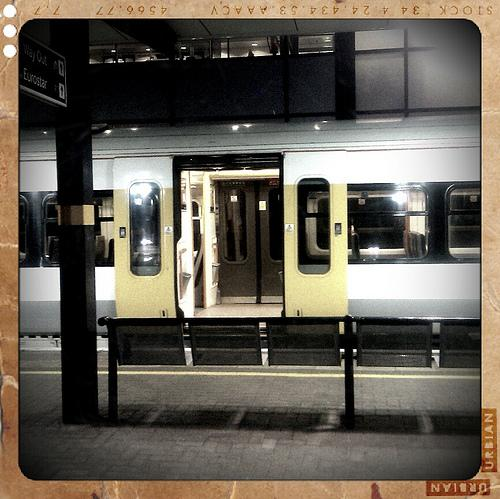What colors are the train doors described as? The train doors are described as white and yellow. What is the function of the mechanism in the image? The mechanism slides the doors open and closed on the train. Express the main sentiment of the image. The main sentiment of the image is of a quiet, empty subway train station waiting for passengers. Identify the primary mode of transportation in the image. The primary mode of transportation is an underground train. What type of pole is mentioned in the image? A metal support pole is mentioned. In the image, where is the light glare reflecting from? The light glare is reflecting off of the train window. Mention the state of the bench in the image. The bench is broken up into sections. List three objects present in the image. Three objects in the image are train, bench, and pillar. Describe the doorway in the image and its condition. The doorway is part of a train stopped at a station, and it is open. Observe the large, graffiti-covered trash can near the signpost. It adds an urban vibe to the station. There is no information about a trash can or graffiti in the given captions. The instruction misleads by implying there is an element of urban art in the image. Notice the cute kitten sitting on the platform, right next to the pillar. The instruction is misleading because there is no caption about a kitten in the given list. It creates a false expectation of seeing an animal in the image. Look for a group of people waiting for the train, gathered near the bench. They appear to be engaged in a conversation. This instruction is misleading because none of the captions mention any people in the image. It creates an incorrect impression of human presence in the scene. Do you see a big clock on the wall above the train door? It shows the current time. This instruction is misleading because there is no mention of a clock in the captions. It suggests that there is a time-telling element in the scene which does not exist. Can you spot the colorful advertisement poster on the wall opposite the train window? It promotes a new movie. There is no mention of an advertisement or poster in any of the given captions. The instruction is misleading as it suggests there is additional visual content within the image that doesn't exist. Can you find the small red bicycle near the bench? It has a basket in the front. There is no mention of a bicycle in any of the given captions. The instruction is misleading because it suggests there should be a bike in the image. 